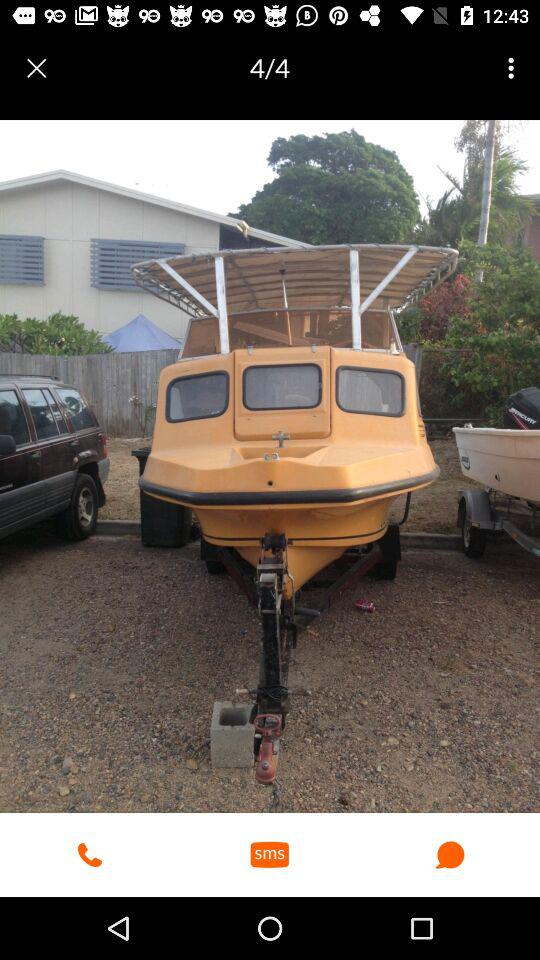What is the total number of photos shown on the screen? The total number of photos is 4. 